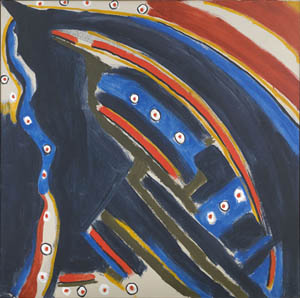Can you describe the main features of this image for me? This image features a visually striking piece of abstract art. The background, a tumultuous blend of deep blue and intense black, sets a mysterious tone. Dominating the composition is a prominent abstract shape, outlined in stark white, which draws immediate attention. This central figure is a complex fusion of blue and black with scattered red, yellow, and white dots, resembling stars across a night sky. The abstract form, open to interpretation, invites viewers to project their emotions and imagination onto it. The style is reminiscent of expressionist movements, particularly echoing the abstract traditions of Wassily Kandinsky. The use of bold, contrasting colors and dynamic shapes encapsulates the emotional intensity and innovative spirit of abstract art. Overall, the artwork invites a personal connection and exploration of its intricate details. 